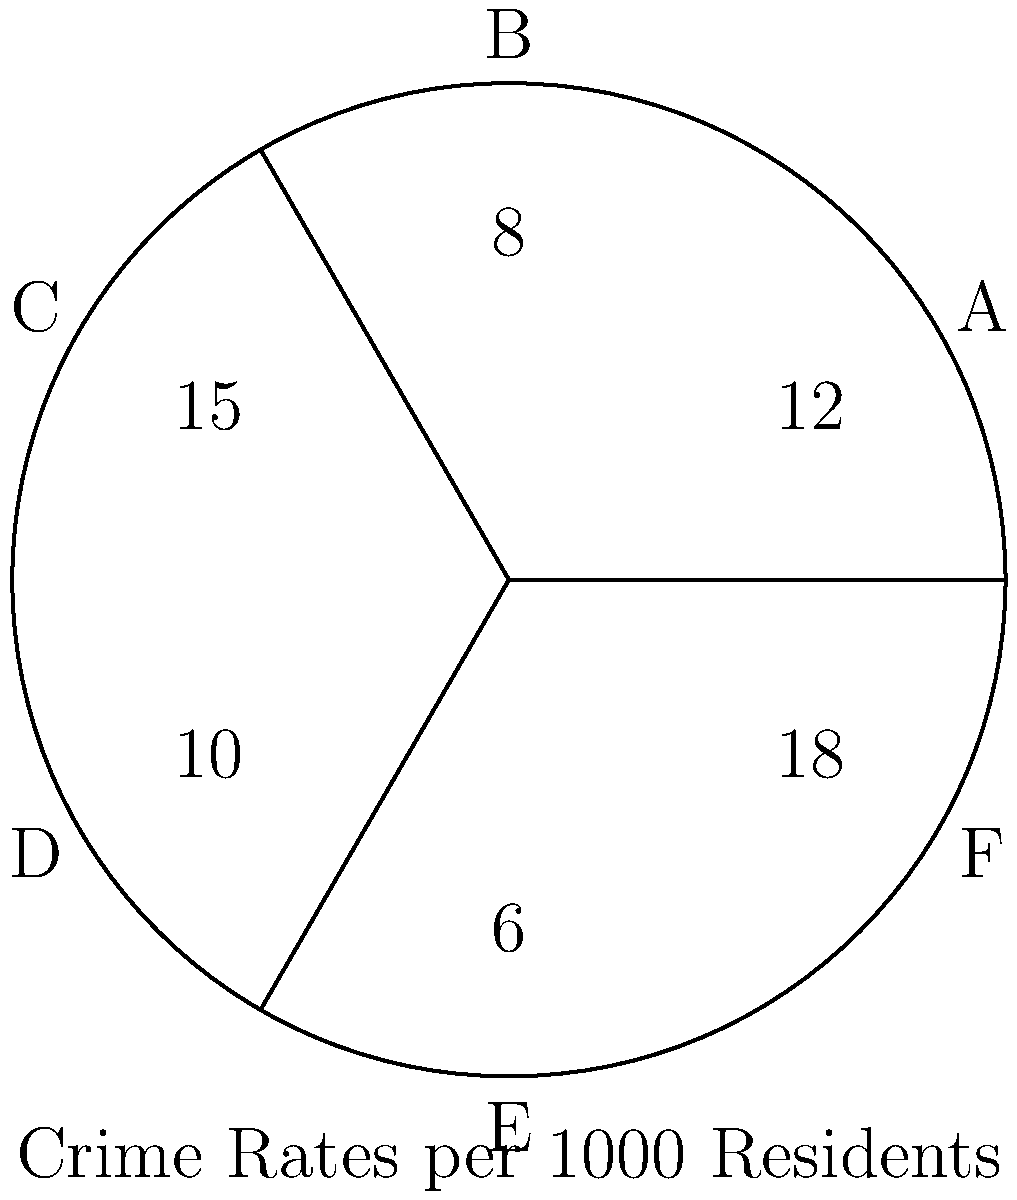As the chair of the local neighborhood watch committee, you're analyzing a circular city diagram divided into six sectors (A to F) with corresponding crime rates per 1000 residents. Which two adjacent sectors have the highest combined crime rate, and what is the difference between their individual rates? To solve this problem, we need to follow these steps:

1. Identify all adjacent sector pairs:
   A-B, B-C, C-D, D-E, E-F, F-A

2. Calculate the combined crime rates for each pair:
   A-B: 12 + 8 = 20
   B-C: 8 + 15 = 23
   C-D: 15 + 10 = 25
   D-E: 10 + 6 = 16
   E-F: 6 + 18 = 24
   F-A: 18 + 12 = 30

3. Identify the pair with the highest combined rate:
   F-A has the highest combined rate of 30.

4. Calculate the difference between the individual rates of F and A:
   $|18 - 12| = 6$

Therefore, sectors F and A have the highest combined crime rate, and the difference between their individual rates is 6 per 1000 residents.
Answer: Sectors F and A; 6 per 1000 residents 